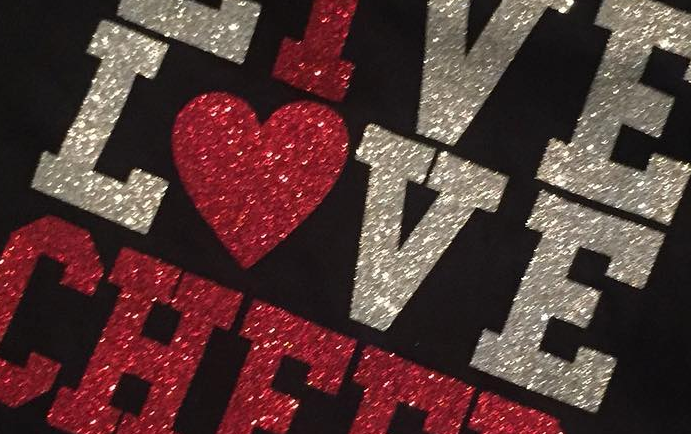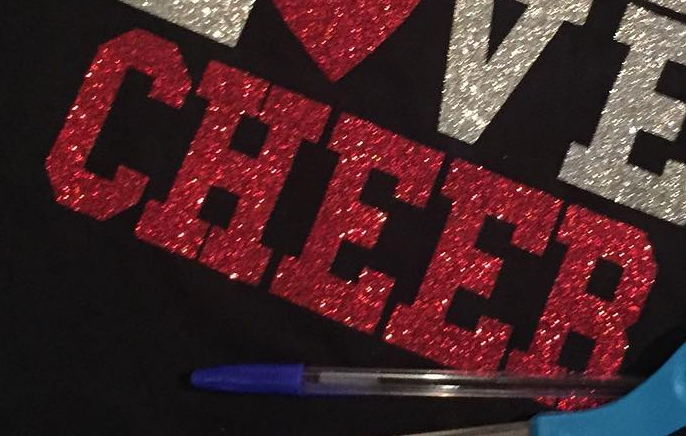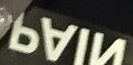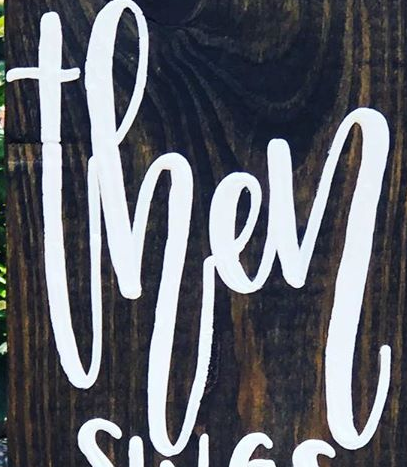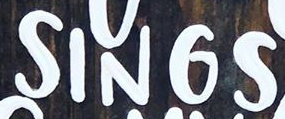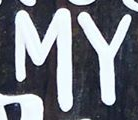What words are shown in these images in order, separated by a semicolon? LOVE; CHEER; NIAP; then; SINGS; MY 